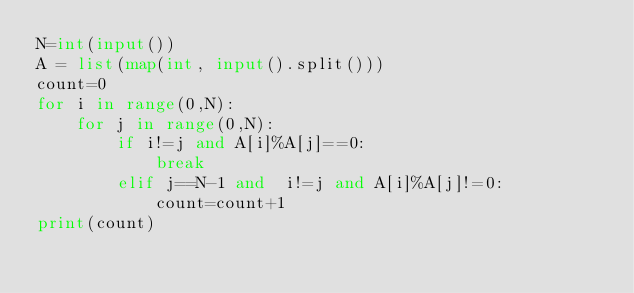Convert code to text. <code><loc_0><loc_0><loc_500><loc_500><_Python_>N=int(input())
A = list(map(int, input().split()))
count=0
for i in range(0,N):
    for j in range(0,N):
        if i!=j and A[i]%A[j]==0:
            break
        elif j==N-1 and  i!=j and A[i]%A[j]!=0:
            count=count+1
print(count)</code> 